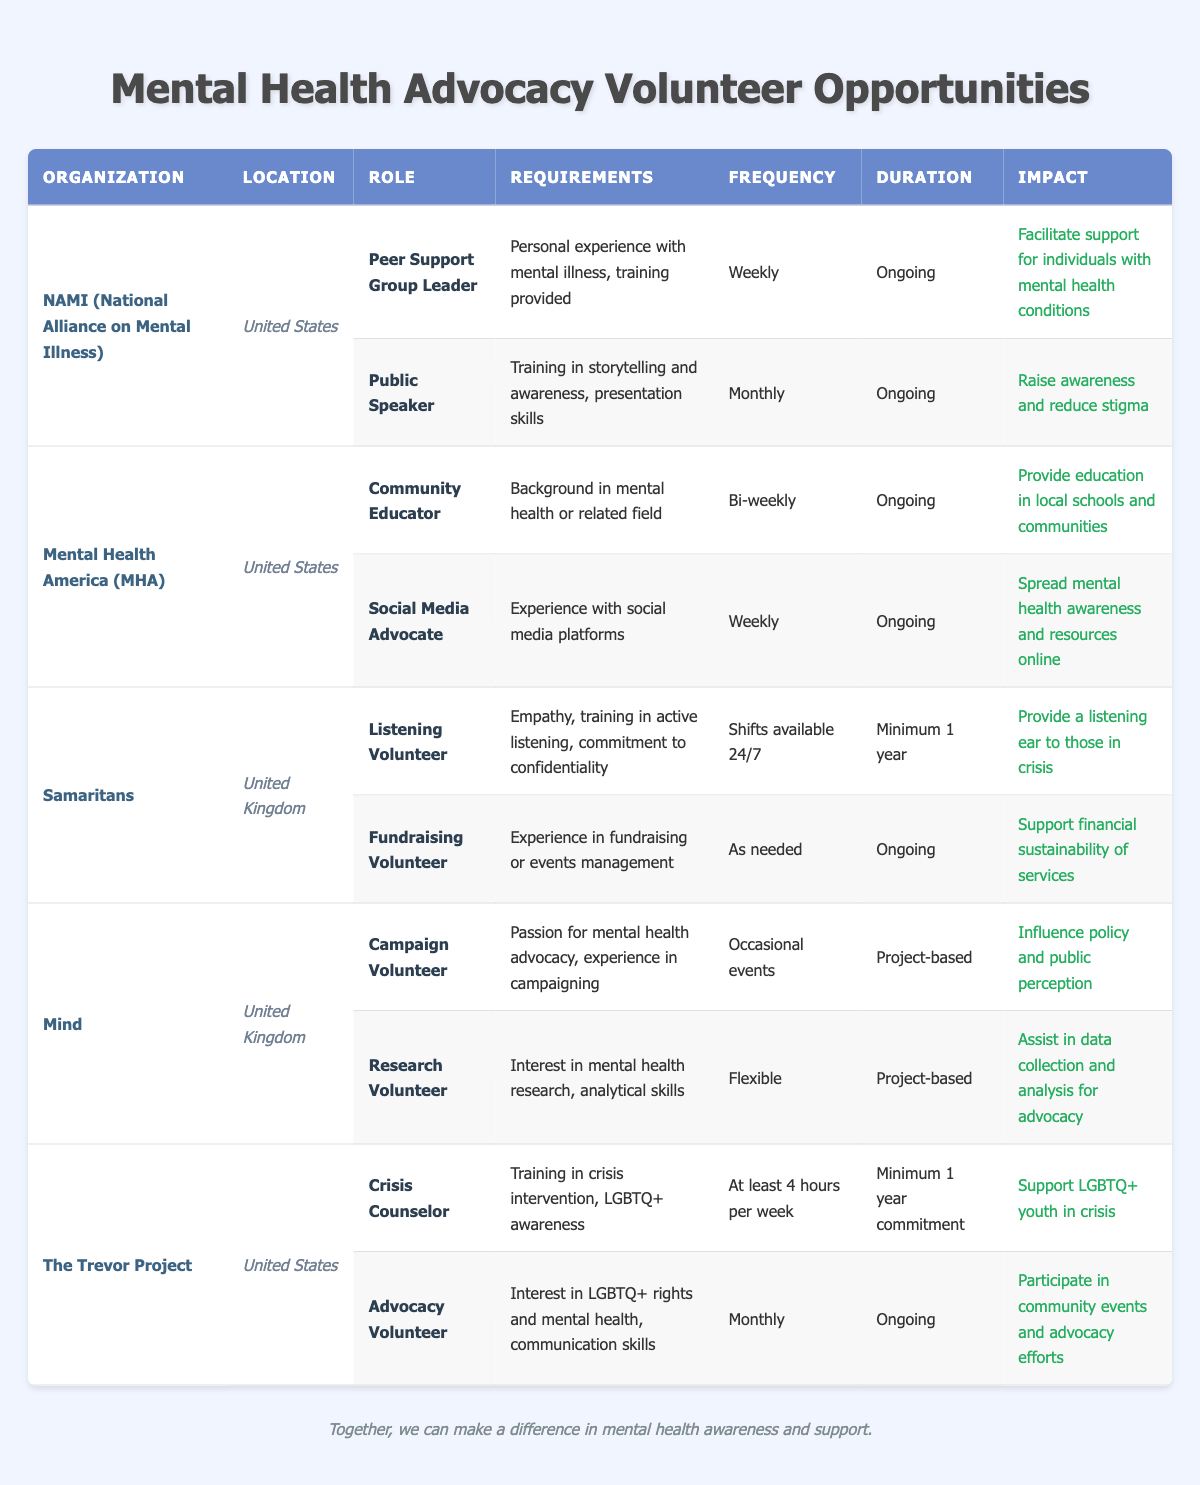What volunteer role at NAMI meets weekly? The table lists "Peer Support Group Leader" as the only volunteer role at NAMI that has a weekly frequency.
Answer: Peer Support Group Leader How often do Social Media Advocates volunteer? According to the table, Social Media Advocates volunteer weekly at Mental Health America.
Answer: Weekly What is the duration of the Listening Volunteer position at Samaritans? The table indicates that the duration for the Listening Volunteer position is a minimum of one year.
Answer: Minimum 1 year Which organization offers a role related to research? The table shows that the "Research Volunteer" position is offered by Mind.
Answer: Mind Is a background in a mental health-related field required for the Community Educator role? Yes, the table states that a background in mental health or a related field is a requirement for the Community Educator role at Mental Health America.
Answer: Yes What is the frequency of the Crisis Counselor role at The Trevor Project? The frequency for the Crisis Counselor role at The Trevor Project is at least four hours per week, as noted in the table.
Answer: At least 4 hours per week Which role has the most significant impact according to the descriptions? The "Crisis Counselor" role at The Trevor Project is crucial as it supports LGBTQ+ youth in crisis, which is a significant impact.
Answer: Crisis Counselor Do both organizations in the United Kingdom have roles that require training? Yes, both Samaritans (Listening Volunteer) and Mind (Research Volunteer) have roles that require training in some capacity as listed in the table.
Answer: Yes How many volunteer opportunities does NAMI have listed? NAMI has two volunteer opportunities listed: Peer Support Group Leader and Public Speaker.
Answer: 2 What is the impact of the Advocacy Volunteer role at The Trevor Project? The impact of the Advocacy Volunteer role is to participate in community events and advocacy efforts as stated in the table.
Answer: Participate in community events and advocacy efforts What are the common durations for roles at Mental Health America? The table lists both roles at Mental Health America as having ongoing durations, which is common for those positions.
Answer: Ongoing How many roles require a specific commitment duration at the organizations listed? At the organizations listed, two roles (Crisis Counselor and Listening Volunteer) specify a minimum commitment duration of one year.
Answer: 2 Which organizations focus on education-related roles? NAMI and Mental Health America both have roles focused on education, specifically Peer Support Group Leader and Community Educator respectively.
Answer: NAMI and Mental Health America What is the frequency of roles at the UK organizations compared to the US organizations? The UK organizations offer roles with varying frequencies including occasional events and flexible, while US organizations tend to have more structured regular engagements like weekly and bi-weekly.
Answer: Varying frequencies What is unique about the Crisis Counselor role's requirements at The Trevor Project? The requirement for training in crisis intervention and LGBTQ+ awareness makes the Crisis Counselor role unique compared to others listed.
Answer: Unique requirements 